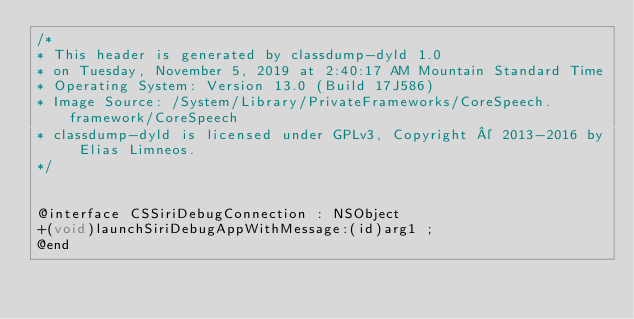<code> <loc_0><loc_0><loc_500><loc_500><_C_>/*
* This header is generated by classdump-dyld 1.0
* on Tuesday, November 5, 2019 at 2:40:17 AM Mountain Standard Time
* Operating System: Version 13.0 (Build 17J586)
* Image Source: /System/Library/PrivateFrameworks/CoreSpeech.framework/CoreSpeech
* classdump-dyld is licensed under GPLv3, Copyright © 2013-2016 by Elias Limneos.
*/


@interface CSSiriDebugConnection : NSObject
+(void)launchSiriDebugAppWithMessage:(id)arg1 ;
@end

</code> 